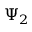Convert formula to latex. <formula><loc_0><loc_0><loc_500><loc_500>\Psi _ { 2 }</formula> 